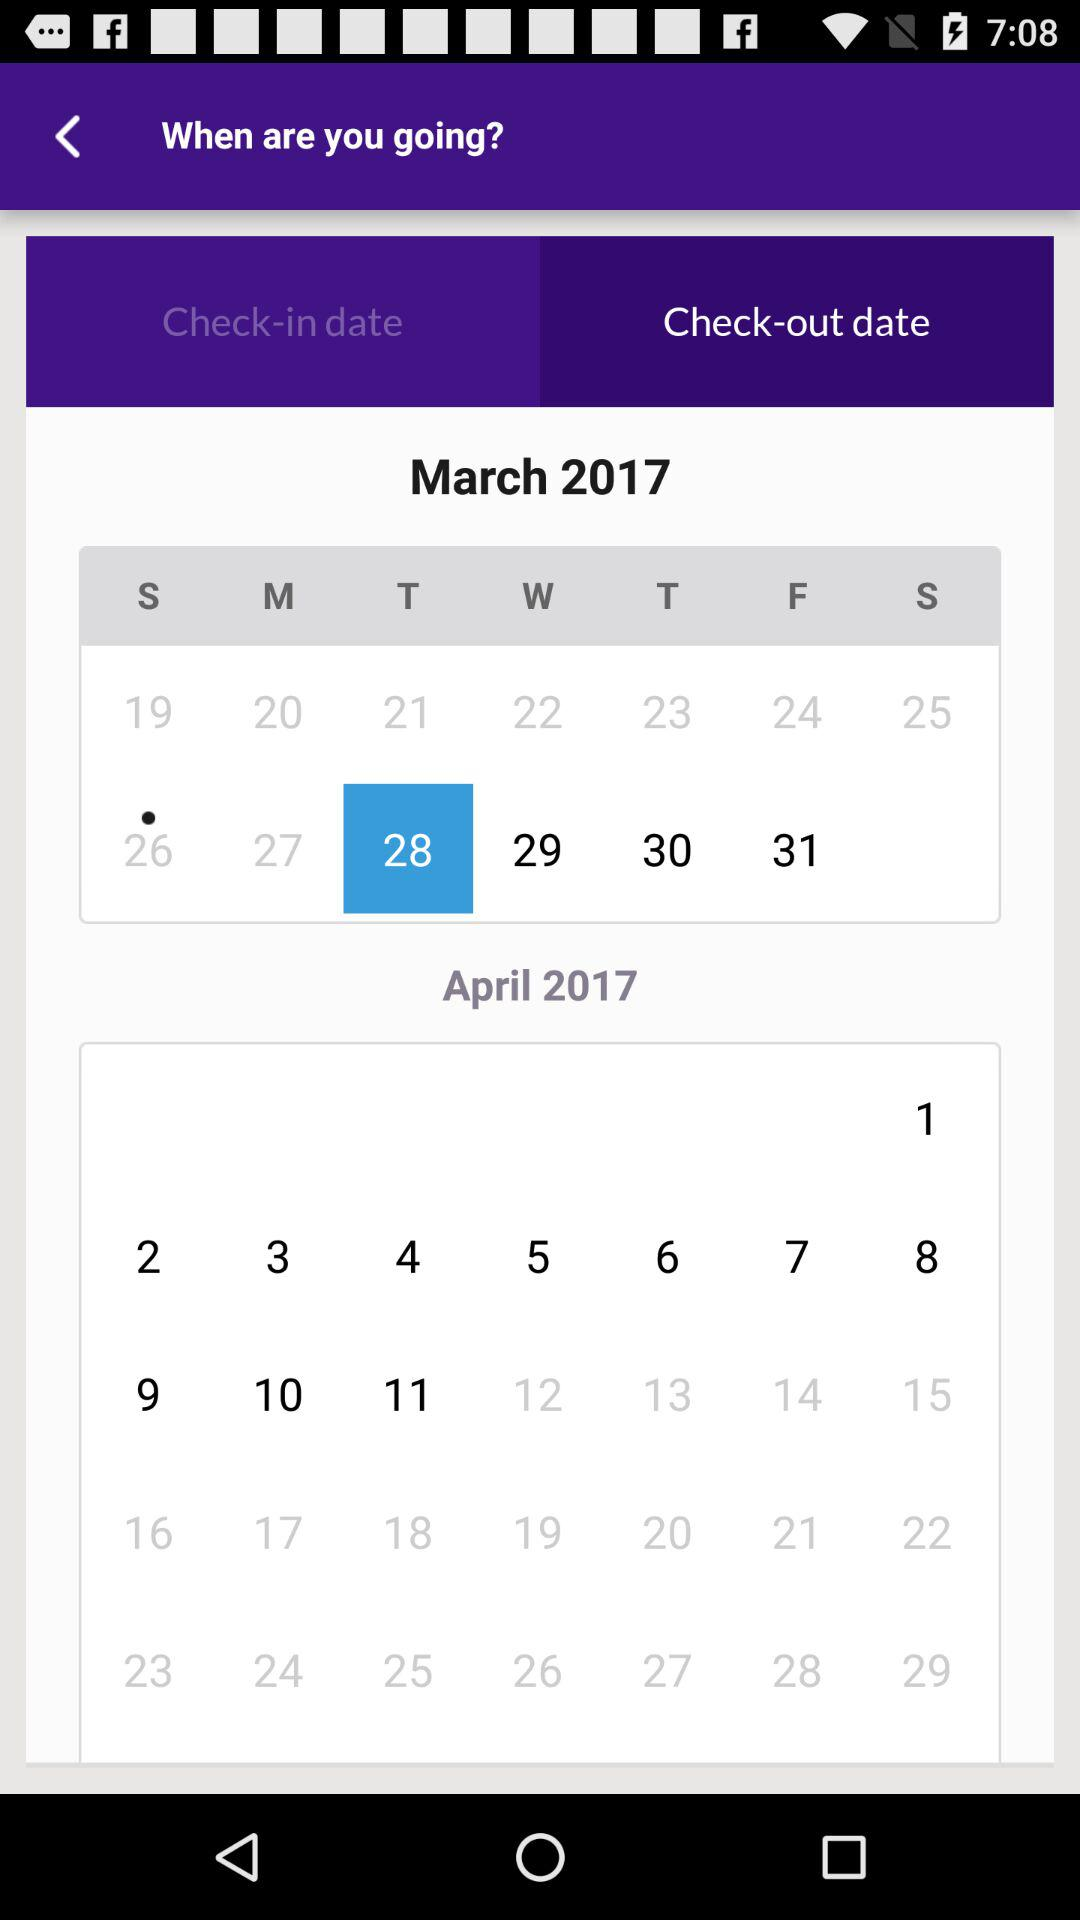What is the date and year of the check-in? The date and year of check-in is Sunday, March 26, 2017. 